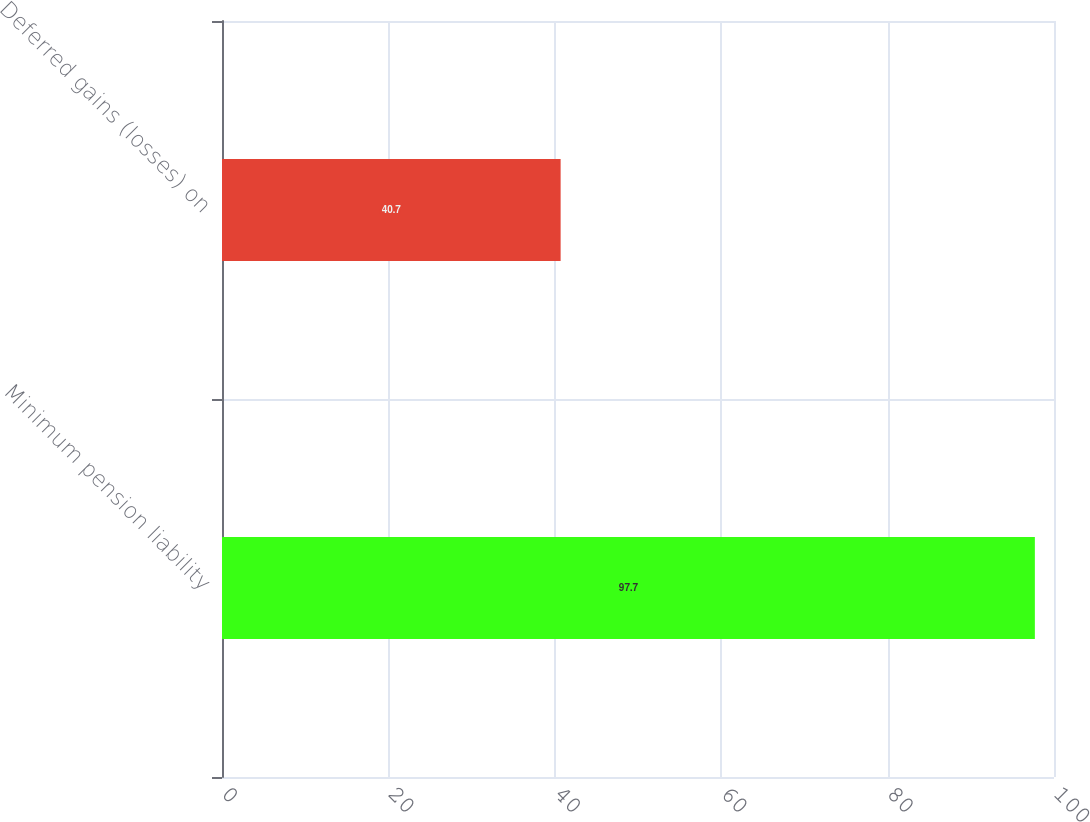Convert chart. <chart><loc_0><loc_0><loc_500><loc_500><bar_chart><fcel>Minimum pension liability<fcel>Deferred gains (losses) on<nl><fcel>97.7<fcel>40.7<nl></chart> 